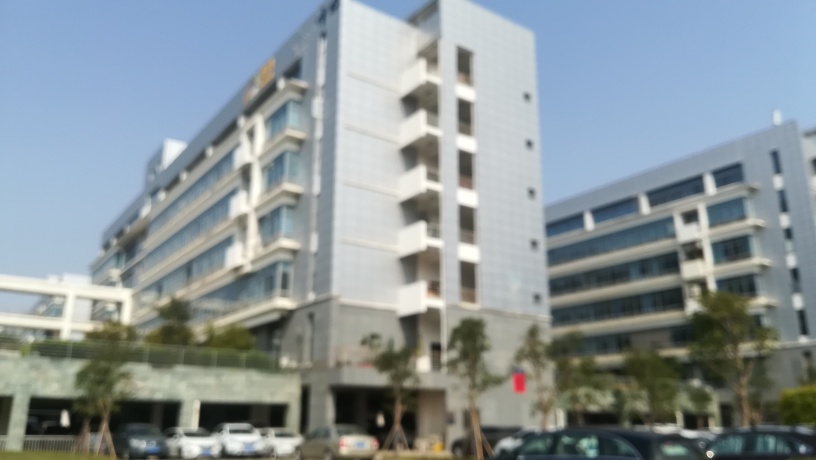Are there focusing issues in the image? Indeed, the image exhibits a lack of sharpness and clarity which suggests focusing issues. This is evident as all subjects in the frame, including the building and parked cars, appear blurry, implying that the image was not properly focused when it was taken. 